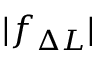Convert formula to latex. <formula><loc_0><loc_0><loc_500><loc_500>| f _ { \Delta L } |</formula> 